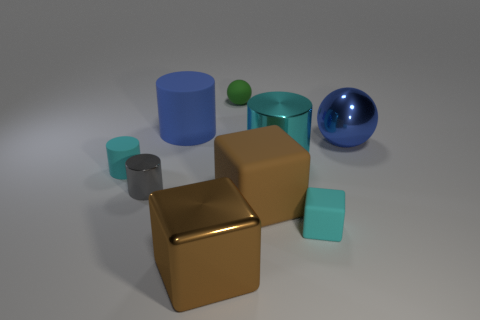Is the number of small blocks behind the green matte thing less than the number of big blue objects?
Your response must be concise. Yes. Is there a thing in front of the tiny cyan rubber thing behind the small metal cylinder?
Ensure brevity in your answer.  Yes. Does the blue sphere have the same size as the brown metal block?
Give a very brief answer. Yes. What is the small cyan object left of the rubber block to the left of the cyan cylinder that is behind the small cyan cylinder made of?
Provide a short and direct response. Rubber. Are there the same number of big blue objects that are left of the tiny gray shiny cylinder and big gray rubber objects?
Your answer should be very brief. Yes. What number of objects are tiny rubber spheres or cyan metallic cubes?
Keep it short and to the point. 1. The blue thing that is the same material as the tiny gray cylinder is what shape?
Ensure brevity in your answer.  Sphere. There is a matte cylinder on the right side of the matte object that is on the left side of the blue matte cylinder; how big is it?
Keep it short and to the point. Large. How many big things are brown objects or green objects?
Your answer should be very brief. 2. How many other objects are the same color as the small ball?
Provide a succinct answer. 0. 